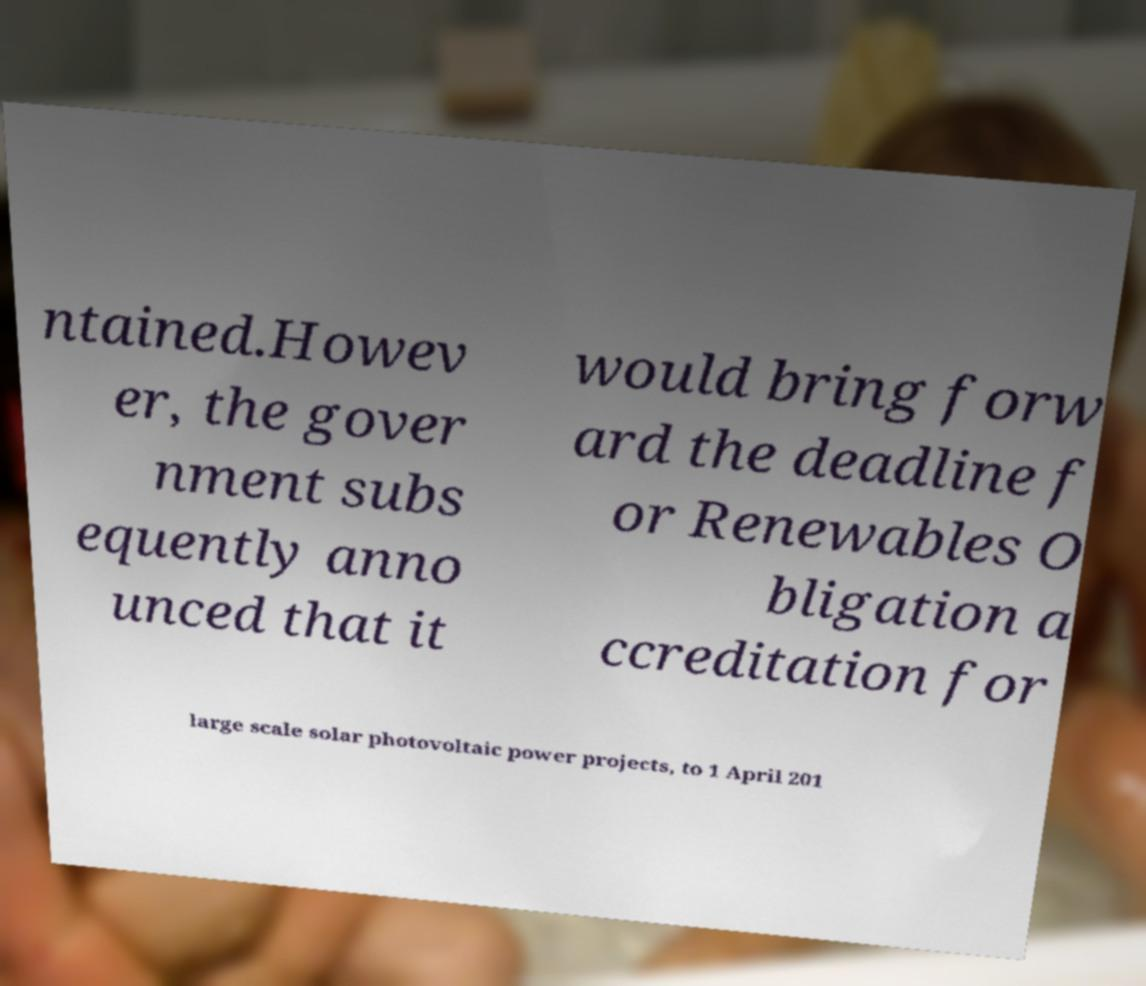Can you accurately transcribe the text from the provided image for me? ntained.Howev er, the gover nment subs equently anno unced that it would bring forw ard the deadline f or Renewables O bligation a ccreditation for large scale solar photovoltaic power projects, to 1 April 201 